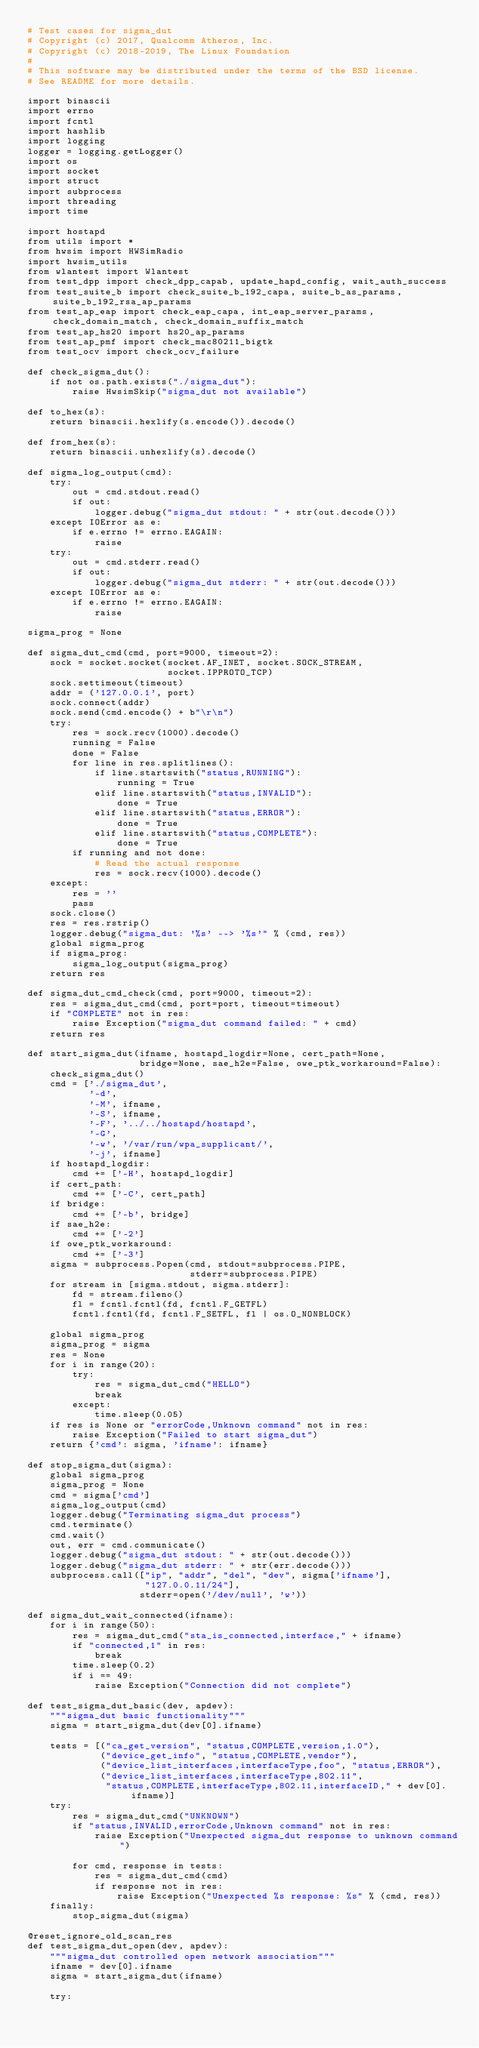<code> <loc_0><loc_0><loc_500><loc_500><_Python_># Test cases for sigma_dut
# Copyright (c) 2017, Qualcomm Atheros, Inc.
# Copyright (c) 2018-2019, The Linux Foundation
#
# This software may be distributed under the terms of the BSD license.
# See README for more details.

import binascii
import errno
import fcntl
import hashlib
import logging
logger = logging.getLogger()
import os
import socket
import struct
import subprocess
import threading
import time

import hostapd
from utils import *
from hwsim import HWSimRadio
import hwsim_utils
from wlantest import Wlantest
from test_dpp import check_dpp_capab, update_hapd_config, wait_auth_success
from test_suite_b import check_suite_b_192_capa, suite_b_as_params, suite_b_192_rsa_ap_params
from test_ap_eap import check_eap_capa, int_eap_server_params, check_domain_match, check_domain_suffix_match
from test_ap_hs20 import hs20_ap_params
from test_ap_pmf import check_mac80211_bigtk
from test_ocv import check_ocv_failure

def check_sigma_dut():
    if not os.path.exists("./sigma_dut"):
        raise HwsimSkip("sigma_dut not available")

def to_hex(s):
    return binascii.hexlify(s.encode()).decode()

def from_hex(s):
    return binascii.unhexlify(s).decode()

def sigma_log_output(cmd):
    try:
        out = cmd.stdout.read()
        if out:
            logger.debug("sigma_dut stdout: " + str(out.decode()))
    except IOError as e:
        if e.errno != errno.EAGAIN:
            raise
    try:
        out = cmd.stderr.read()
        if out:
            logger.debug("sigma_dut stderr: " + str(out.decode()))
    except IOError as e:
        if e.errno != errno.EAGAIN:
            raise

sigma_prog = None

def sigma_dut_cmd(cmd, port=9000, timeout=2):
    sock = socket.socket(socket.AF_INET, socket.SOCK_STREAM,
                         socket.IPPROTO_TCP)
    sock.settimeout(timeout)
    addr = ('127.0.0.1', port)
    sock.connect(addr)
    sock.send(cmd.encode() + b"\r\n")
    try:
        res = sock.recv(1000).decode()
        running = False
        done = False
        for line in res.splitlines():
            if line.startswith("status,RUNNING"):
                running = True
            elif line.startswith("status,INVALID"):
                done = True
            elif line.startswith("status,ERROR"):
                done = True
            elif line.startswith("status,COMPLETE"):
                done = True
        if running and not done:
            # Read the actual response
            res = sock.recv(1000).decode()
    except:
        res = ''
        pass
    sock.close()
    res = res.rstrip()
    logger.debug("sigma_dut: '%s' --> '%s'" % (cmd, res))
    global sigma_prog
    if sigma_prog:
        sigma_log_output(sigma_prog)
    return res

def sigma_dut_cmd_check(cmd, port=9000, timeout=2):
    res = sigma_dut_cmd(cmd, port=port, timeout=timeout)
    if "COMPLETE" not in res:
        raise Exception("sigma_dut command failed: " + cmd)
    return res

def start_sigma_dut(ifname, hostapd_logdir=None, cert_path=None,
                    bridge=None, sae_h2e=False, owe_ptk_workaround=False):
    check_sigma_dut()
    cmd = ['./sigma_dut',
           '-d',
           '-M', ifname,
           '-S', ifname,
           '-F', '../../hostapd/hostapd',
           '-G',
           '-w', '/var/run/wpa_supplicant/',
           '-j', ifname]
    if hostapd_logdir:
        cmd += ['-H', hostapd_logdir]
    if cert_path:
        cmd += ['-C', cert_path]
    if bridge:
        cmd += ['-b', bridge]
    if sae_h2e:
        cmd += ['-2']
    if owe_ptk_workaround:
        cmd += ['-3']
    sigma = subprocess.Popen(cmd, stdout=subprocess.PIPE,
                             stderr=subprocess.PIPE)
    for stream in [sigma.stdout, sigma.stderr]:
        fd = stream.fileno()
        fl = fcntl.fcntl(fd, fcntl.F_GETFL)
        fcntl.fcntl(fd, fcntl.F_SETFL, fl | os.O_NONBLOCK)

    global sigma_prog
    sigma_prog = sigma
    res = None
    for i in range(20):
        try:
            res = sigma_dut_cmd("HELLO")
            break
        except:
            time.sleep(0.05)
    if res is None or "errorCode,Unknown command" not in res:
        raise Exception("Failed to start sigma_dut")
    return {'cmd': sigma, 'ifname': ifname}

def stop_sigma_dut(sigma):
    global sigma_prog
    sigma_prog = None
    cmd = sigma['cmd']
    sigma_log_output(cmd)
    logger.debug("Terminating sigma_dut process")
    cmd.terminate()
    cmd.wait()
    out, err = cmd.communicate()
    logger.debug("sigma_dut stdout: " + str(out.decode()))
    logger.debug("sigma_dut stderr: " + str(err.decode()))
    subprocess.call(["ip", "addr", "del", "dev", sigma['ifname'],
                     "127.0.0.11/24"],
                    stderr=open('/dev/null', 'w'))

def sigma_dut_wait_connected(ifname):
    for i in range(50):
        res = sigma_dut_cmd("sta_is_connected,interface," + ifname)
        if "connected,1" in res:
            break
        time.sleep(0.2)
        if i == 49:
            raise Exception("Connection did not complete")

def test_sigma_dut_basic(dev, apdev):
    """sigma_dut basic functionality"""
    sigma = start_sigma_dut(dev[0].ifname)

    tests = [("ca_get_version", "status,COMPLETE,version,1.0"),
             ("device_get_info", "status,COMPLETE,vendor"),
             ("device_list_interfaces,interfaceType,foo", "status,ERROR"),
             ("device_list_interfaces,interfaceType,802.11",
              "status,COMPLETE,interfaceType,802.11,interfaceID," + dev[0].ifname)]
    try:
        res = sigma_dut_cmd("UNKNOWN")
        if "status,INVALID,errorCode,Unknown command" not in res:
            raise Exception("Unexpected sigma_dut response to unknown command")

        for cmd, response in tests:
            res = sigma_dut_cmd(cmd)
            if response not in res:
                raise Exception("Unexpected %s response: %s" % (cmd, res))
    finally:
        stop_sigma_dut(sigma)

@reset_ignore_old_scan_res
def test_sigma_dut_open(dev, apdev):
    """sigma_dut controlled open network association"""
    ifname = dev[0].ifname
    sigma = start_sigma_dut(ifname)

    try:</code> 